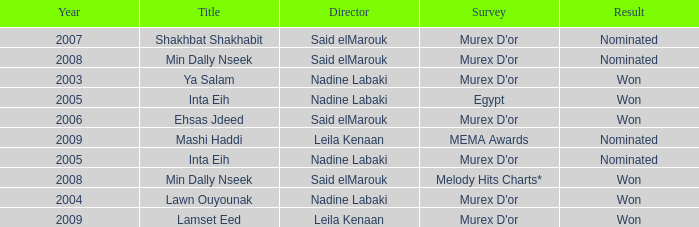What is the title for the Murex D'or survey, after 2005, Said Elmarouk as director, and was nominated? Shakhbat Shakhabit, Min Dally Nseek. 